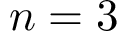<formula> <loc_0><loc_0><loc_500><loc_500>n = 3</formula> 